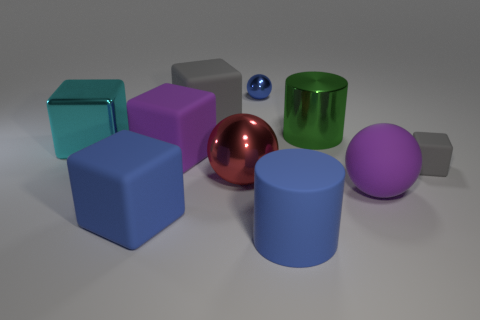Subtract all big blue blocks. How many blocks are left? 4 Subtract all purple balls. How many balls are left? 2 Subtract 1 blocks. How many blocks are left? 4 Subtract all cylinders. How many objects are left? 8 Subtract all yellow cylinders. How many green cubes are left? 0 Subtract all small red metal blocks. Subtract all big blue matte blocks. How many objects are left? 9 Add 9 large red metal balls. How many large red metal balls are left? 10 Add 4 large gray rubber objects. How many large gray rubber objects exist? 5 Subtract 0 gray balls. How many objects are left? 10 Subtract all brown cylinders. Subtract all brown spheres. How many cylinders are left? 2 